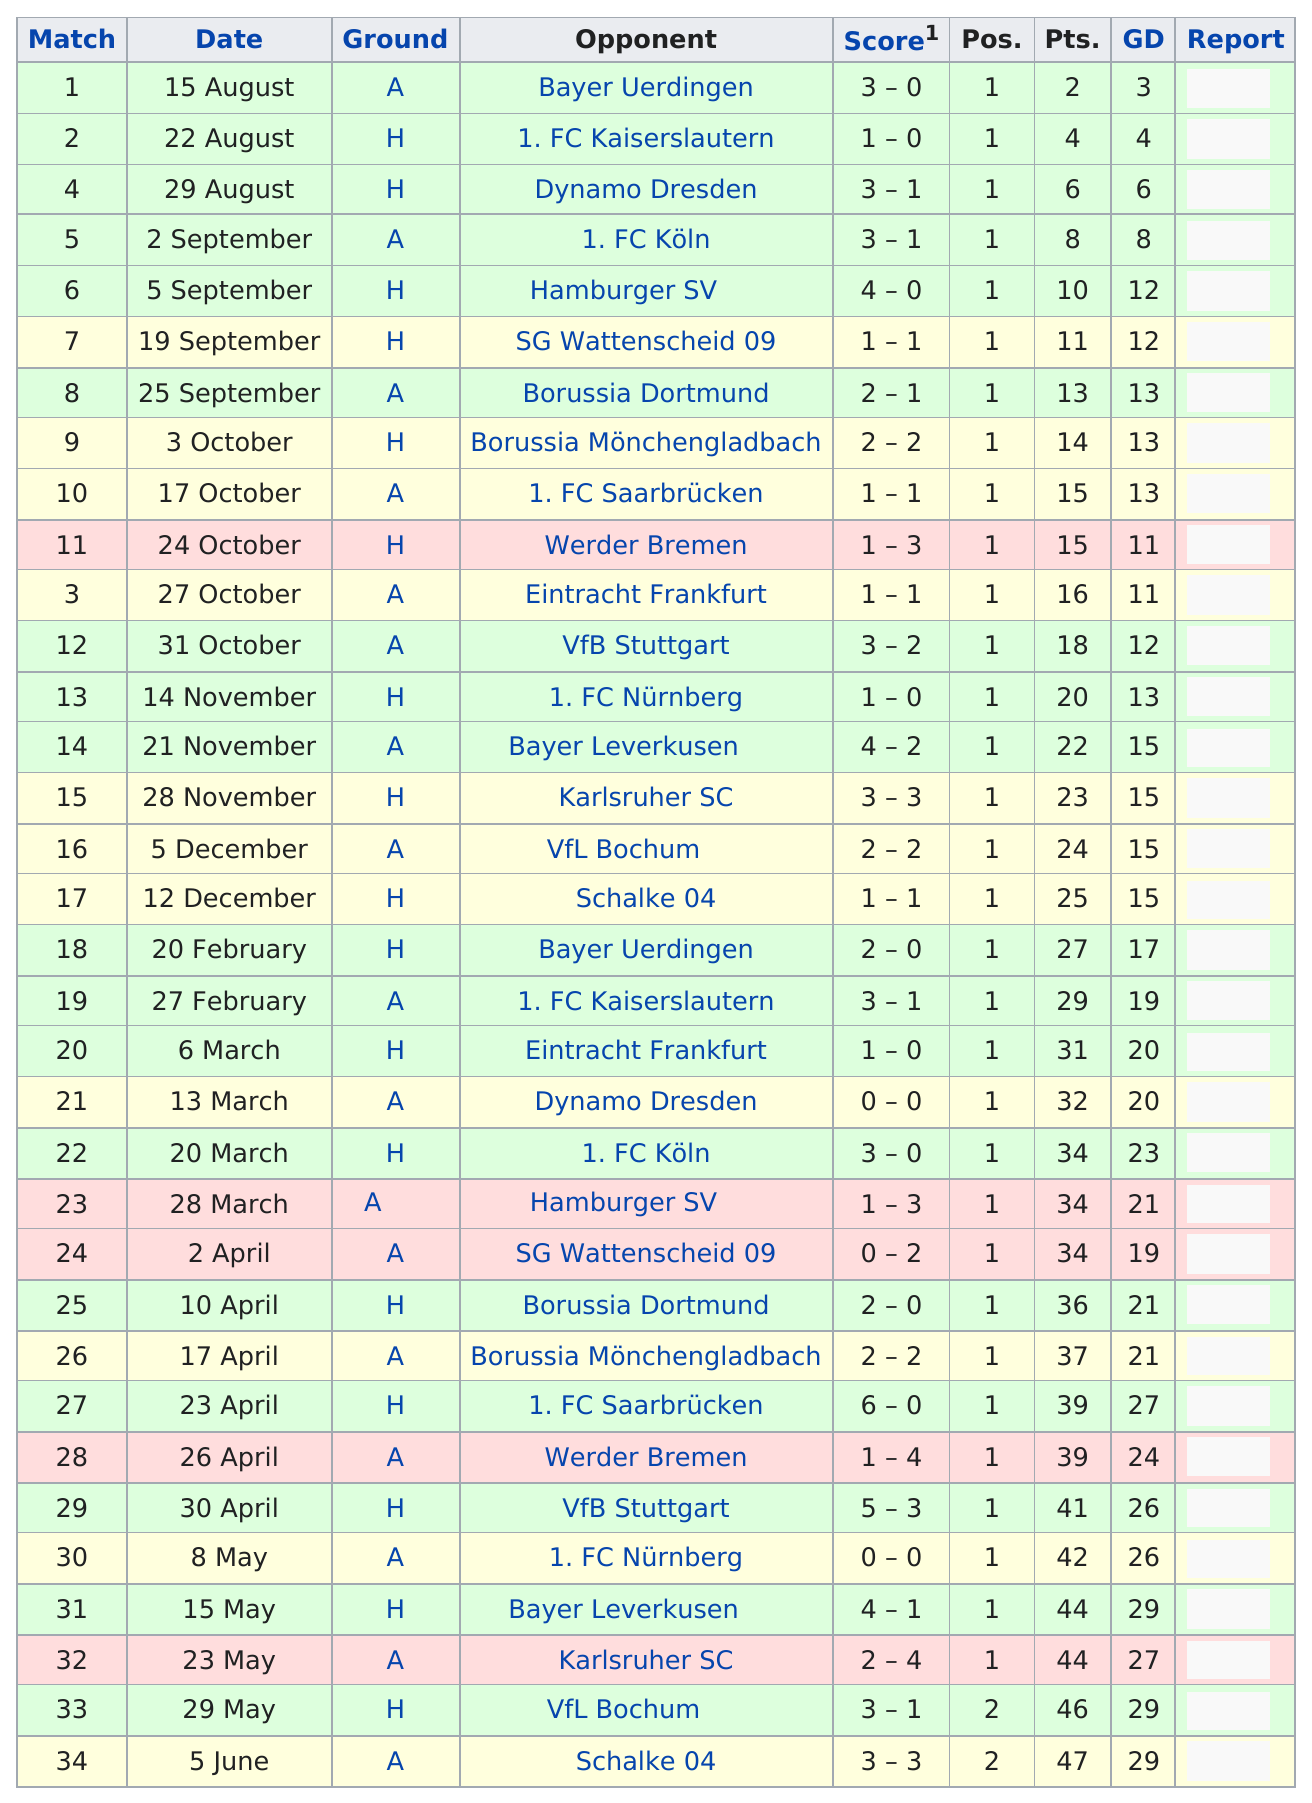Specify some key components in this picture. In April, they played a total of 6 games. There were 9 games that ended in a tie. The last opponent that our club played in August was Dynamo Dresden, and we emerged victorious. On August 15th, Bayer Uerdingen was the opponent. Borussia Dortmund emerged victorious with a score of 2-1 in their most recent match. 